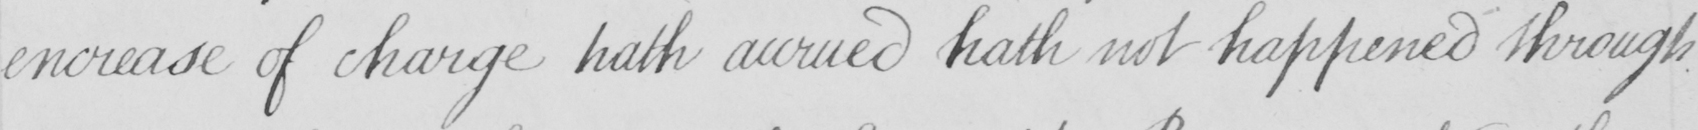Can you read and transcribe this handwriting? encrease of charge hath accrued hath not happened through 